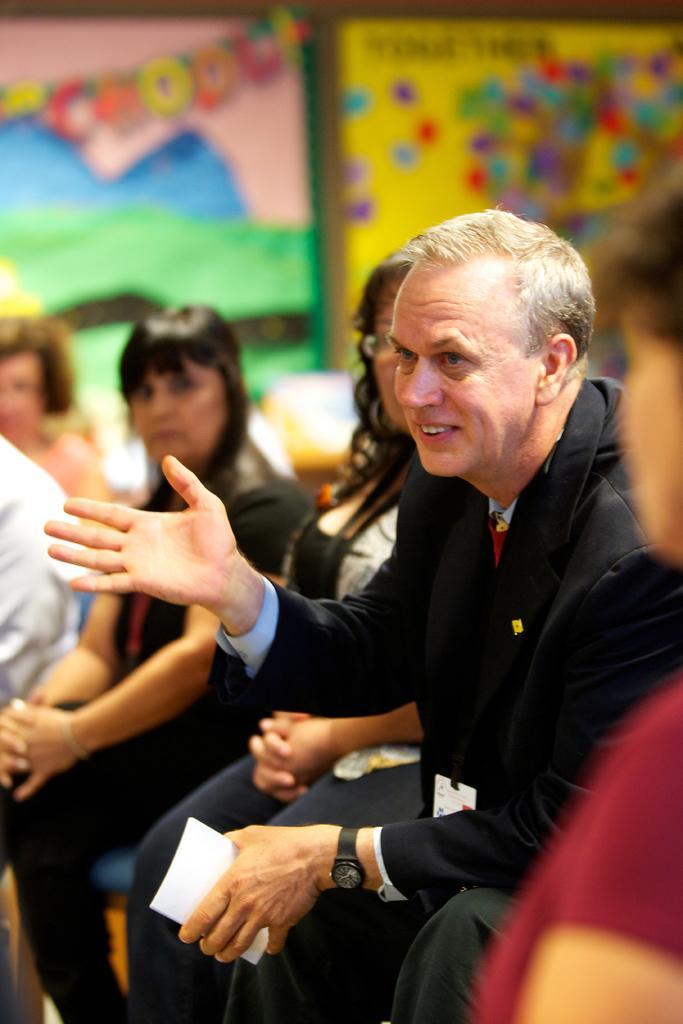How would you summarize this image in a sentence or two? In this picture we can see there is a group of people sitting. A man in the black blazer is holding an object and he is explaining something. Behind the people there are some blurred objects. 